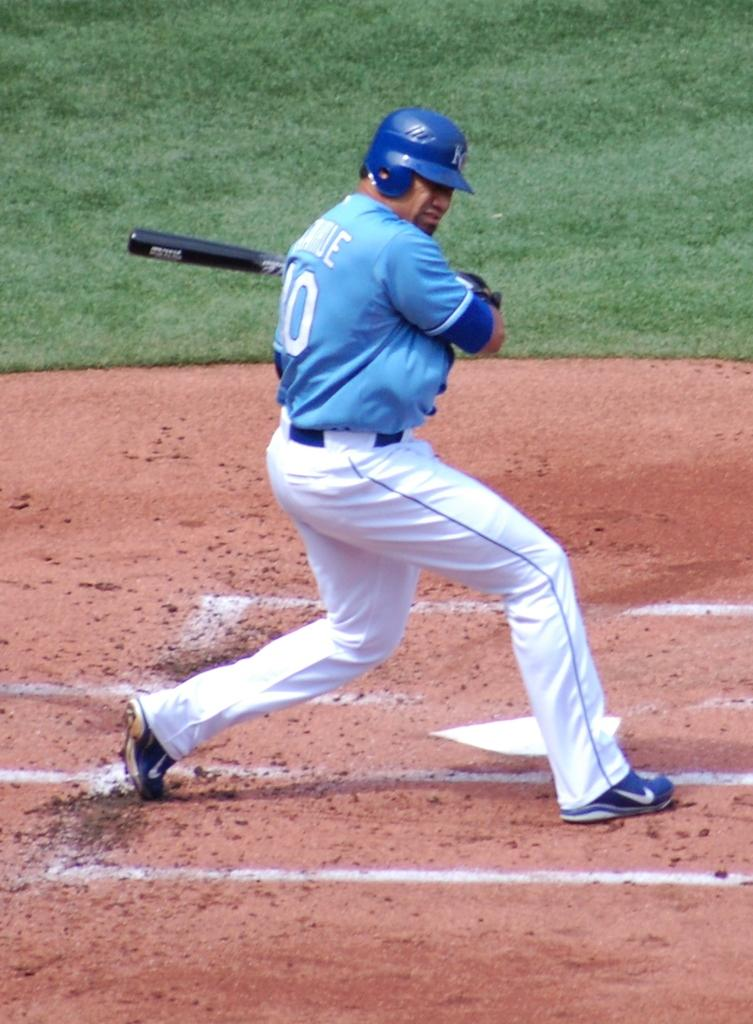What is the main subject of the image? There is a person in the image. What is the person wearing? The person is wearing a helmet. What object is the person holding? The person is holding a baseball bat. What type of surface is the person standing on? The person is standing on a surface. What can be seen in the background of the image? There is green grass visible in the image. What type of lawyer is present at the party in the image? There is no lawyer or party present in the image; it features a person wearing a helmet and holding a baseball bat. Where is the park located in the image? There is no park present in the image; it features a person standing on a surface with green grass visible in the background. 